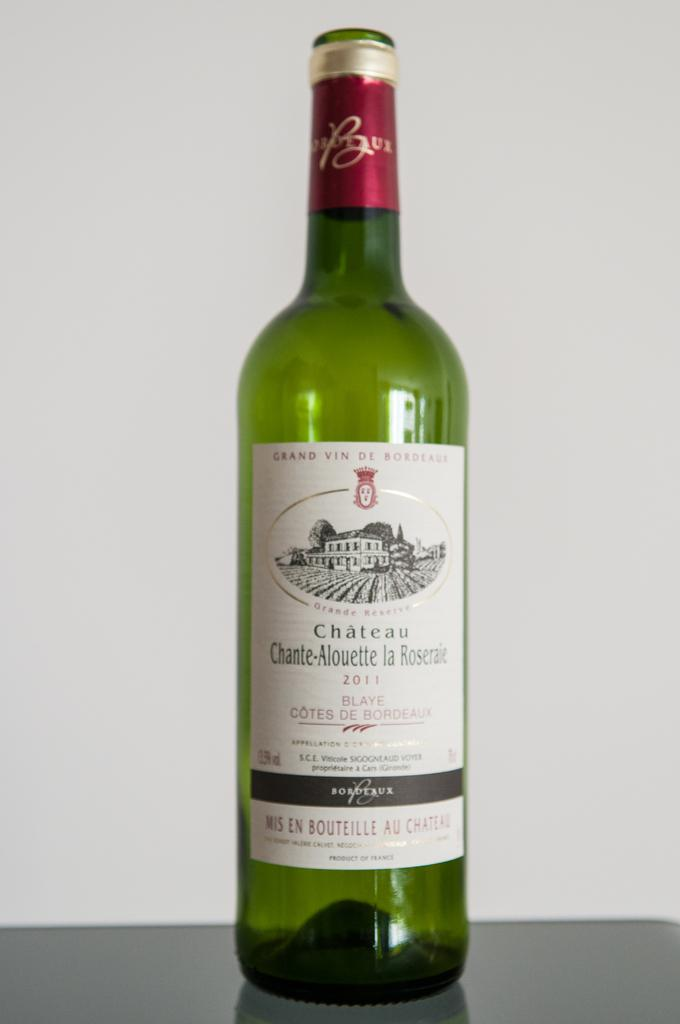<image>
Render a clear and concise summary of the photo. A wine bottle called "Chàteau Chante-Alouette la Roseraie" is sitting on top of a table. 